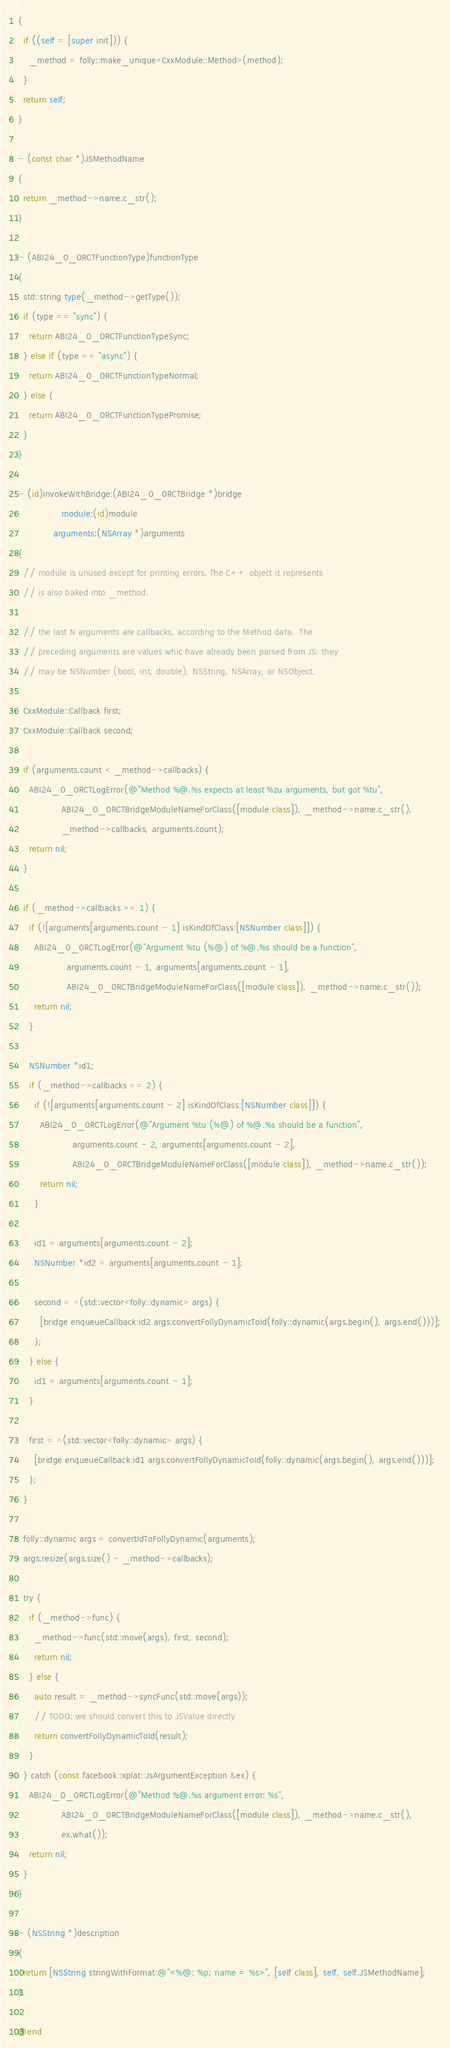Convert code to text. <code><loc_0><loc_0><loc_500><loc_500><_ObjectiveC_>{
  if ((self = [super init])) {
    _method = folly::make_unique<CxxModule::Method>(method);
  }
  return self;
}

- (const char *)JSMethodName
{
  return _method->name.c_str();
}

- (ABI24_0_0RCTFunctionType)functionType
{
  std::string type(_method->getType());
  if (type == "sync") {
    return ABI24_0_0RCTFunctionTypeSync;
  } else if (type == "async") {
    return ABI24_0_0RCTFunctionTypeNormal;
  } else {
    return ABI24_0_0RCTFunctionTypePromise;
  }
}

- (id)invokeWithBridge:(ABI24_0_0RCTBridge *)bridge
                module:(id)module
             arguments:(NSArray *)arguments
{
  // module is unused except for printing errors. The C++ object it represents
  // is also baked into _method.

  // the last N arguments are callbacks, according to the Method data.  The
  // preceding arguments are values whic have already been parsed from JS: they
  // may be NSNumber (bool, int, double), NSString, NSArray, or NSObject.

  CxxModule::Callback first;
  CxxModule::Callback second;

  if (arguments.count < _method->callbacks) {
    ABI24_0_0RCTLogError(@"Method %@.%s expects at least %zu arguments, but got %tu",
                ABI24_0_0RCTBridgeModuleNameForClass([module class]), _method->name.c_str(),
                _method->callbacks, arguments.count);
    return nil;
  }

  if (_method->callbacks >= 1) {
    if (![arguments[arguments.count - 1] isKindOfClass:[NSNumber class]]) {
      ABI24_0_0RCTLogError(@"Argument %tu (%@) of %@.%s should be a function",
                  arguments.count - 1, arguments[arguments.count - 1],
                  ABI24_0_0RCTBridgeModuleNameForClass([module class]), _method->name.c_str());
      return nil;
    }

    NSNumber *id1;
    if (_method->callbacks == 2) {
      if (![arguments[arguments.count - 2] isKindOfClass:[NSNumber class]]) {
        ABI24_0_0RCTLogError(@"Argument %tu (%@) of %@.%s should be a function",
                    arguments.count - 2, arguments[arguments.count - 2],
                    ABI24_0_0RCTBridgeModuleNameForClass([module class]), _method->name.c_str());
        return nil;
      }

      id1 = arguments[arguments.count - 2];
      NSNumber *id2 = arguments[arguments.count - 1];

      second = ^(std::vector<folly::dynamic> args) {
        [bridge enqueueCallback:id2 args:convertFollyDynamicToId(folly::dynamic(args.begin(), args.end()))];
      };
    } else {
      id1 = arguments[arguments.count - 1];
    }

    first = ^(std::vector<folly::dynamic> args) {
      [bridge enqueueCallback:id1 args:convertFollyDynamicToId(folly::dynamic(args.begin(), args.end()))];
    };
  }

  folly::dynamic args = convertIdToFollyDynamic(arguments);
  args.resize(args.size() - _method->callbacks);

  try {
    if (_method->func) {
      _method->func(std::move(args), first, second);
      return nil;
    } else {
      auto result = _method->syncFunc(std::move(args));
      // TODO: we should convert this to JSValue directly
      return convertFollyDynamicToId(result);
    }
  } catch (const facebook::xplat::JsArgumentException &ex) {
    ABI24_0_0RCTLogError(@"Method %@.%s argument error: %s",
                ABI24_0_0RCTBridgeModuleNameForClass([module class]), _method->name.c_str(),
                ex.what());
    return nil;
  }
}

- (NSString *)description
{
  return [NSString stringWithFormat:@"<%@: %p; name = %s>", [self class], self, self.JSMethodName];
}

@end
</code> 